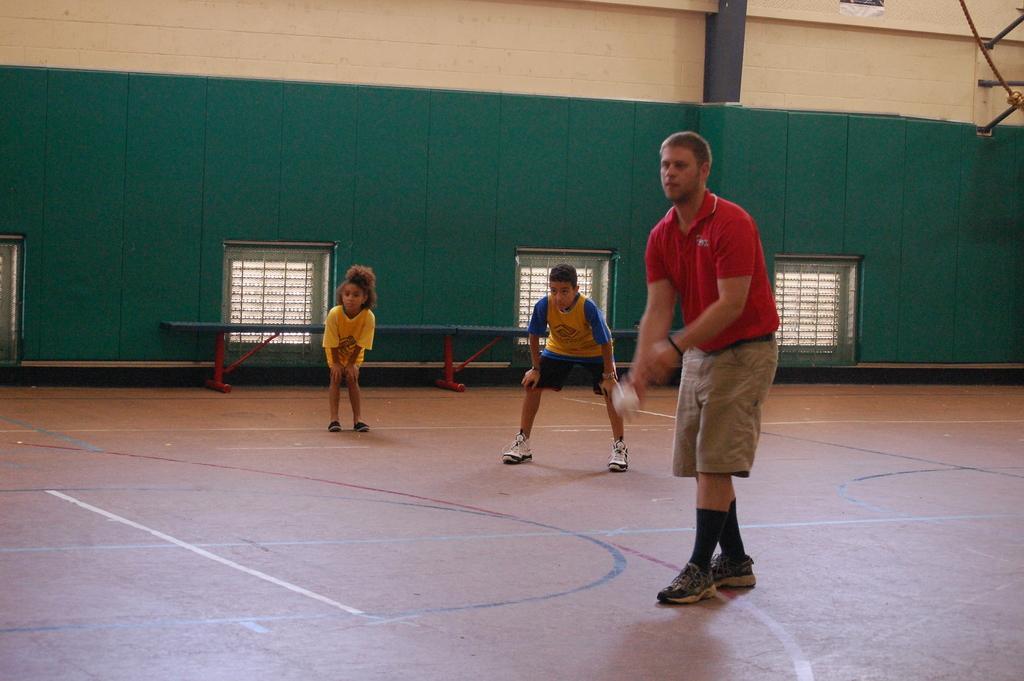Describe this image in one or two sentences. As we can see in the image there is a house, windows, three people over here. The man standing in the front is wearing red color t shirt and holding a white color ball. 